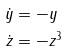<formula> <loc_0><loc_0><loc_500><loc_500>\dot { y } & = - y \\ \dot { z } & = - z ^ { 3 }</formula> 